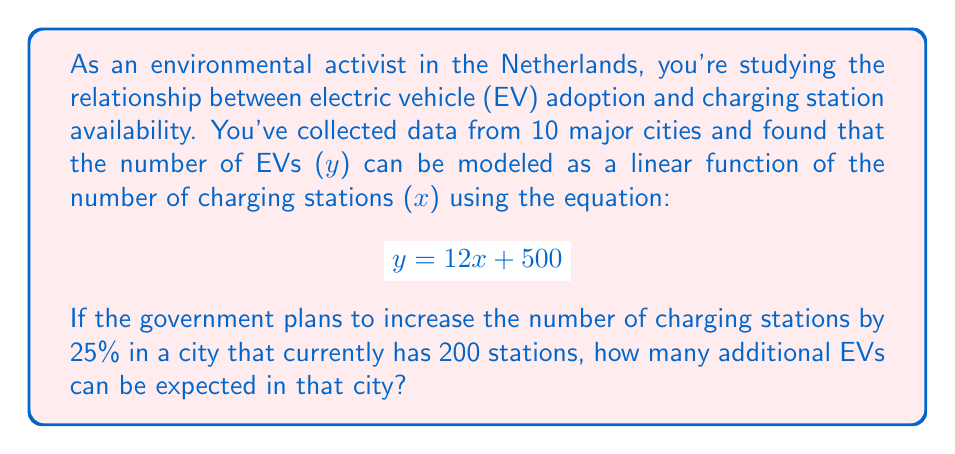Provide a solution to this math problem. Let's approach this problem step-by-step:

1) First, we need to determine the current number of EVs in the city:
   With 200 charging stations, we can substitute $x = 200$ into our equation:
   $$y = 12(200) + 500 = 2400 + 500 = 2900$$
   So there are currently 2900 EVs in the city.

2) Now, let's calculate the new number of charging stations after a 25% increase:
   $200 \times 1.25 = 250$ charging stations

3) With 250 charging stations, we can calculate the new number of EVs:
   $$y = 12(250) + 500 = 3000 + 500 = 3500$$

4) To find the additional number of EVs, we subtract the original number from the new number:
   $$3500 - 2900 = 600$$

Therefore, an additional 600 EVs can be expected in the city after the 25% increase in charging stations.
Answer: 600 additional EVs 